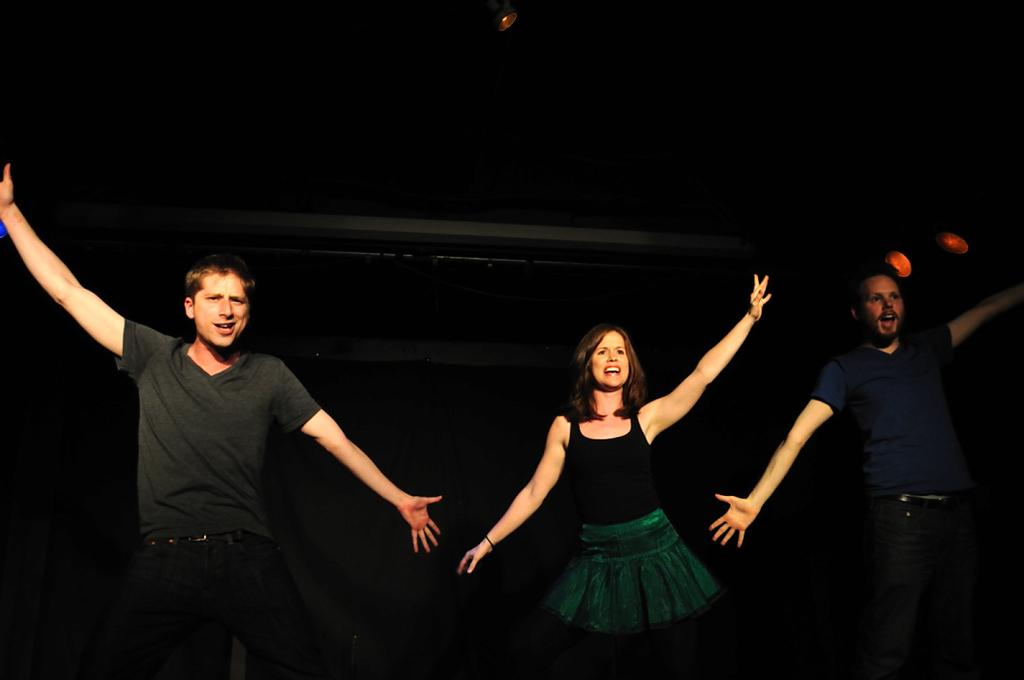Who or what can be seen in the image? There are people in the image. What can be observed about the background of the image? The background of the image is dark. Is there a river flowing through the hair of the people in the image? There is no river or hair visible in the image; it only features people with a dark background. 